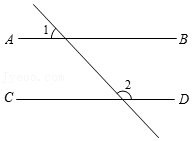Within the figure, AB is parallel to CD and angle 1 measures 56°. What is the measure of angle 2 in degrees? Given that lines AB and CD are parallel, and considering the angle 1 measures 56°, by the properties of parallel lines and transversal angles, angle 1 and angle 3 are equal as they are corresponding angles. Thus, angle 3 also measures 56°. To find angle 2, we can use the fact that angle 2 and angle 3 are supplementary angles (they add up to 180° because they are on a straight line). Therefore, angle 2 = 180° - 56° = 124°. Hence, the measure of angle 2 is 124°. 